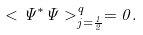Convert formula to latex. <formula><loc_0><loc_0><loc_500><loc_500>< \Psi ^ { * } \Psi > _ { j = \frac { 1 } { 2 } } ^ { q } = 0 .</formula> 